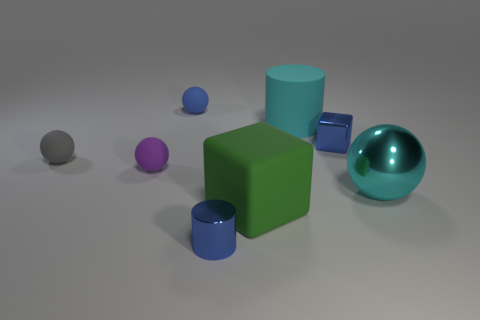What size is the object that is both in front of the cyan metallic object and to the right of the small blue cylinder?
Your answer should be compact. Large. How many other objects are the same material as the small blue cylinder?
Your response must be concise. 2. What is the size of the blue shiny thing that is left of the big green matte cube?
Your answer should be very brief. Small. Is the color of the large cylinder the same as the large matte cube?
Offer a very short reply. No. How many small things are either cyan cylinders or shiny cubes?
Provide a succinct answer. 1. Are there any other things of the same color as the tiny block?
Make the answer very short. Yes. There is a rubber cube; are there any small purple balls to the right of it?
Offer a terse response. No. There is a ball right of the tiny blue thing left of the shiny cylinder; how big is it?
Provide a succinct answer. Large. Is the number of rubber objects that are in front of the tiny shiny block the same as the number of blue metallic cubes in front of the big block?
Give a very brief answer. No. There is a big cyan thing that is behind the cyan shiny ball; are there any small matte objects that are behind it?
Provide a succinct answer. Yes. 